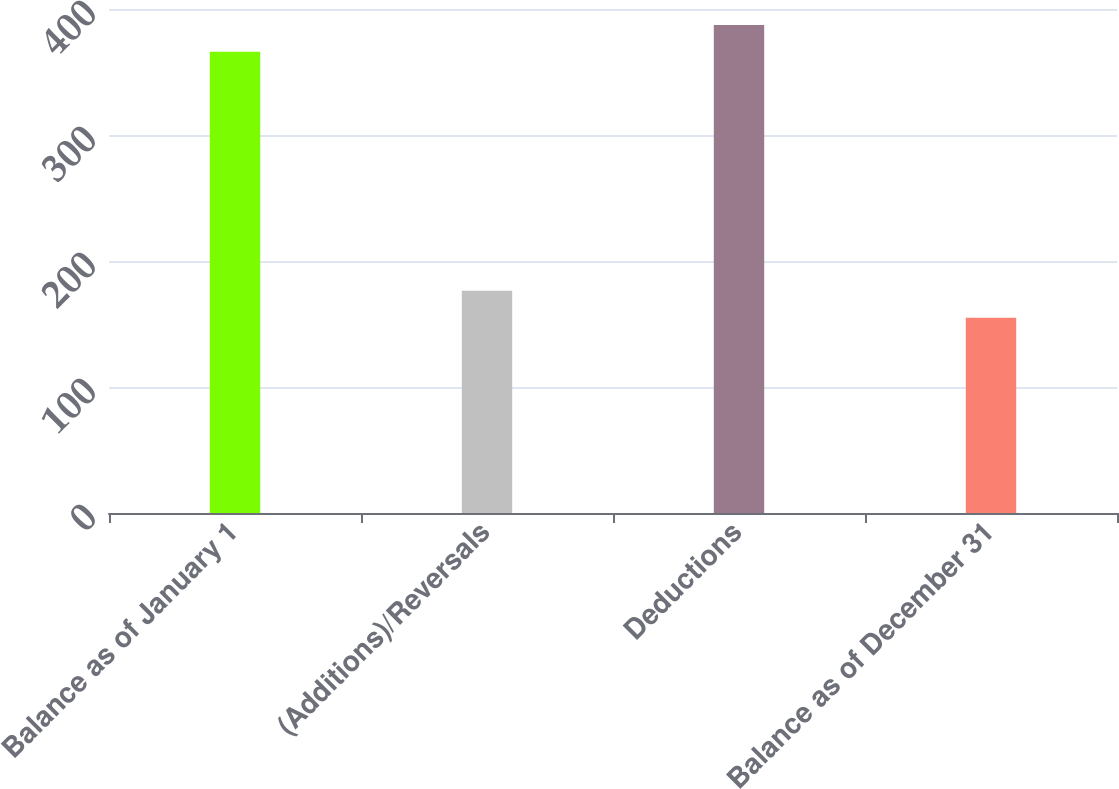<chart> <loc_0><loc_0><loc_500><loc_500><bar_chart><fcel>Balance as of January 1<fcel>(Additions)/Reversals<fcel>Deductions<fcel>Balance as of December 31<nl><fcel>366<fcel>176.3<fcel>387.3<fcel>155<nl></chart> 